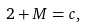Convert formula to latex. <formula><loc_0><loc_0><loc_500><loc_500>2 + M = c ,</formula> 